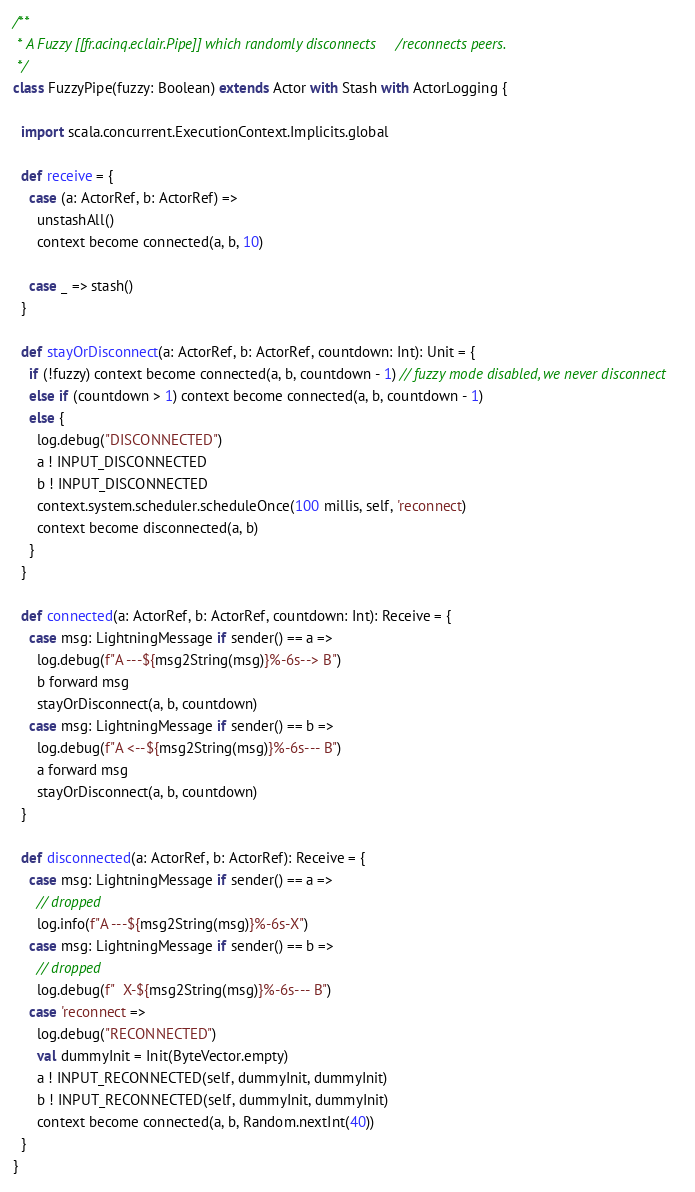Convert code to text. <code><loc_0><loc_0><loc_500><loc_500><_Scala_>
/**
 * A Fuzzy [[fr.acinq.eclair.Pipe]] which randomly disconnects/reconnects peers.
 */
class FuzzyPipe(fuzzy: Boolean) extends Actor with Stash with ActorLogging {

  import scala.concurrent.ExecutionContext.Implicits.global

  def receive = {
    case (a: ActorRef, b: ActorRef) =>
      unstashAll()
      context become connected(a, b, 10)

    case _ => stash()
  }

  def stayOrDisconnect(a: ActorRef, b: ActorRef, countdown: Int): Unit = {
    if (!fuzzy) context become connected(a, b, countdown - 1) // fuzzy mode disabled, we never disconnect
    else if (countdown > 1) context become connected(a, b, countdown - 1)
    else {
      log.debug("DISCONNECTED")
      a ! INPUT_DISCONNECTED
      b ! INPUT_DISCONNECTED
      context.system.scheduler.scheduleOnce(100 millis, self, 'reconnect)
      context become disconnected(a, b)
    }
  }

  def connected(a: ActorRef, b: ActorRef, countdown: Int): Receive = {
    case msg: LightningMessage if sender() == a =>
      log.debug(f"A ---${msg2String(msg)}%-6s--> B")
      b forward msg
      stayOrDisconnect(a, b, countdown)
    case msg: LightningMessage if sender() == b =>
      log.debug(f"A <--${msg2String(msg)}%-6s--- B")
      a forward msg
      stayOrDisconnect(a, b, countdown)
  }

  def disconnected(a: ActorRef, b: ActorRef): Receive = {
    case msg: LightningMessage if sender() == a =>
      // dropped
      log.info(f"A ---${msg2String(msg)}%-6s-X")
    case msg: LightningMessage if sender() == b =>
      // dropped
      log.debug(f"  X-${msg2String(msg)}%-6s--- B")
    case 'reconnect =>
      log.debug("RECONNECTED")
      val dummyInit = Init(ByteVector.empty)
      a ! INPUT_RECONNECTED(self, dummyInit, dummyInit)
      b ! INPUT_RECONNECTED(self, dummyInit, dummyInit)
      context become connected(a, b, Random.nextInt(40))
  }
}
</code> 